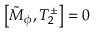Convert formula to latex. <formula><loc_0><loc_0><loc_500><loc_500>\left [ \tilde { M } _ { \phi } , T _ { 2 } ^ { \pm } \right ] = 0</formula> 